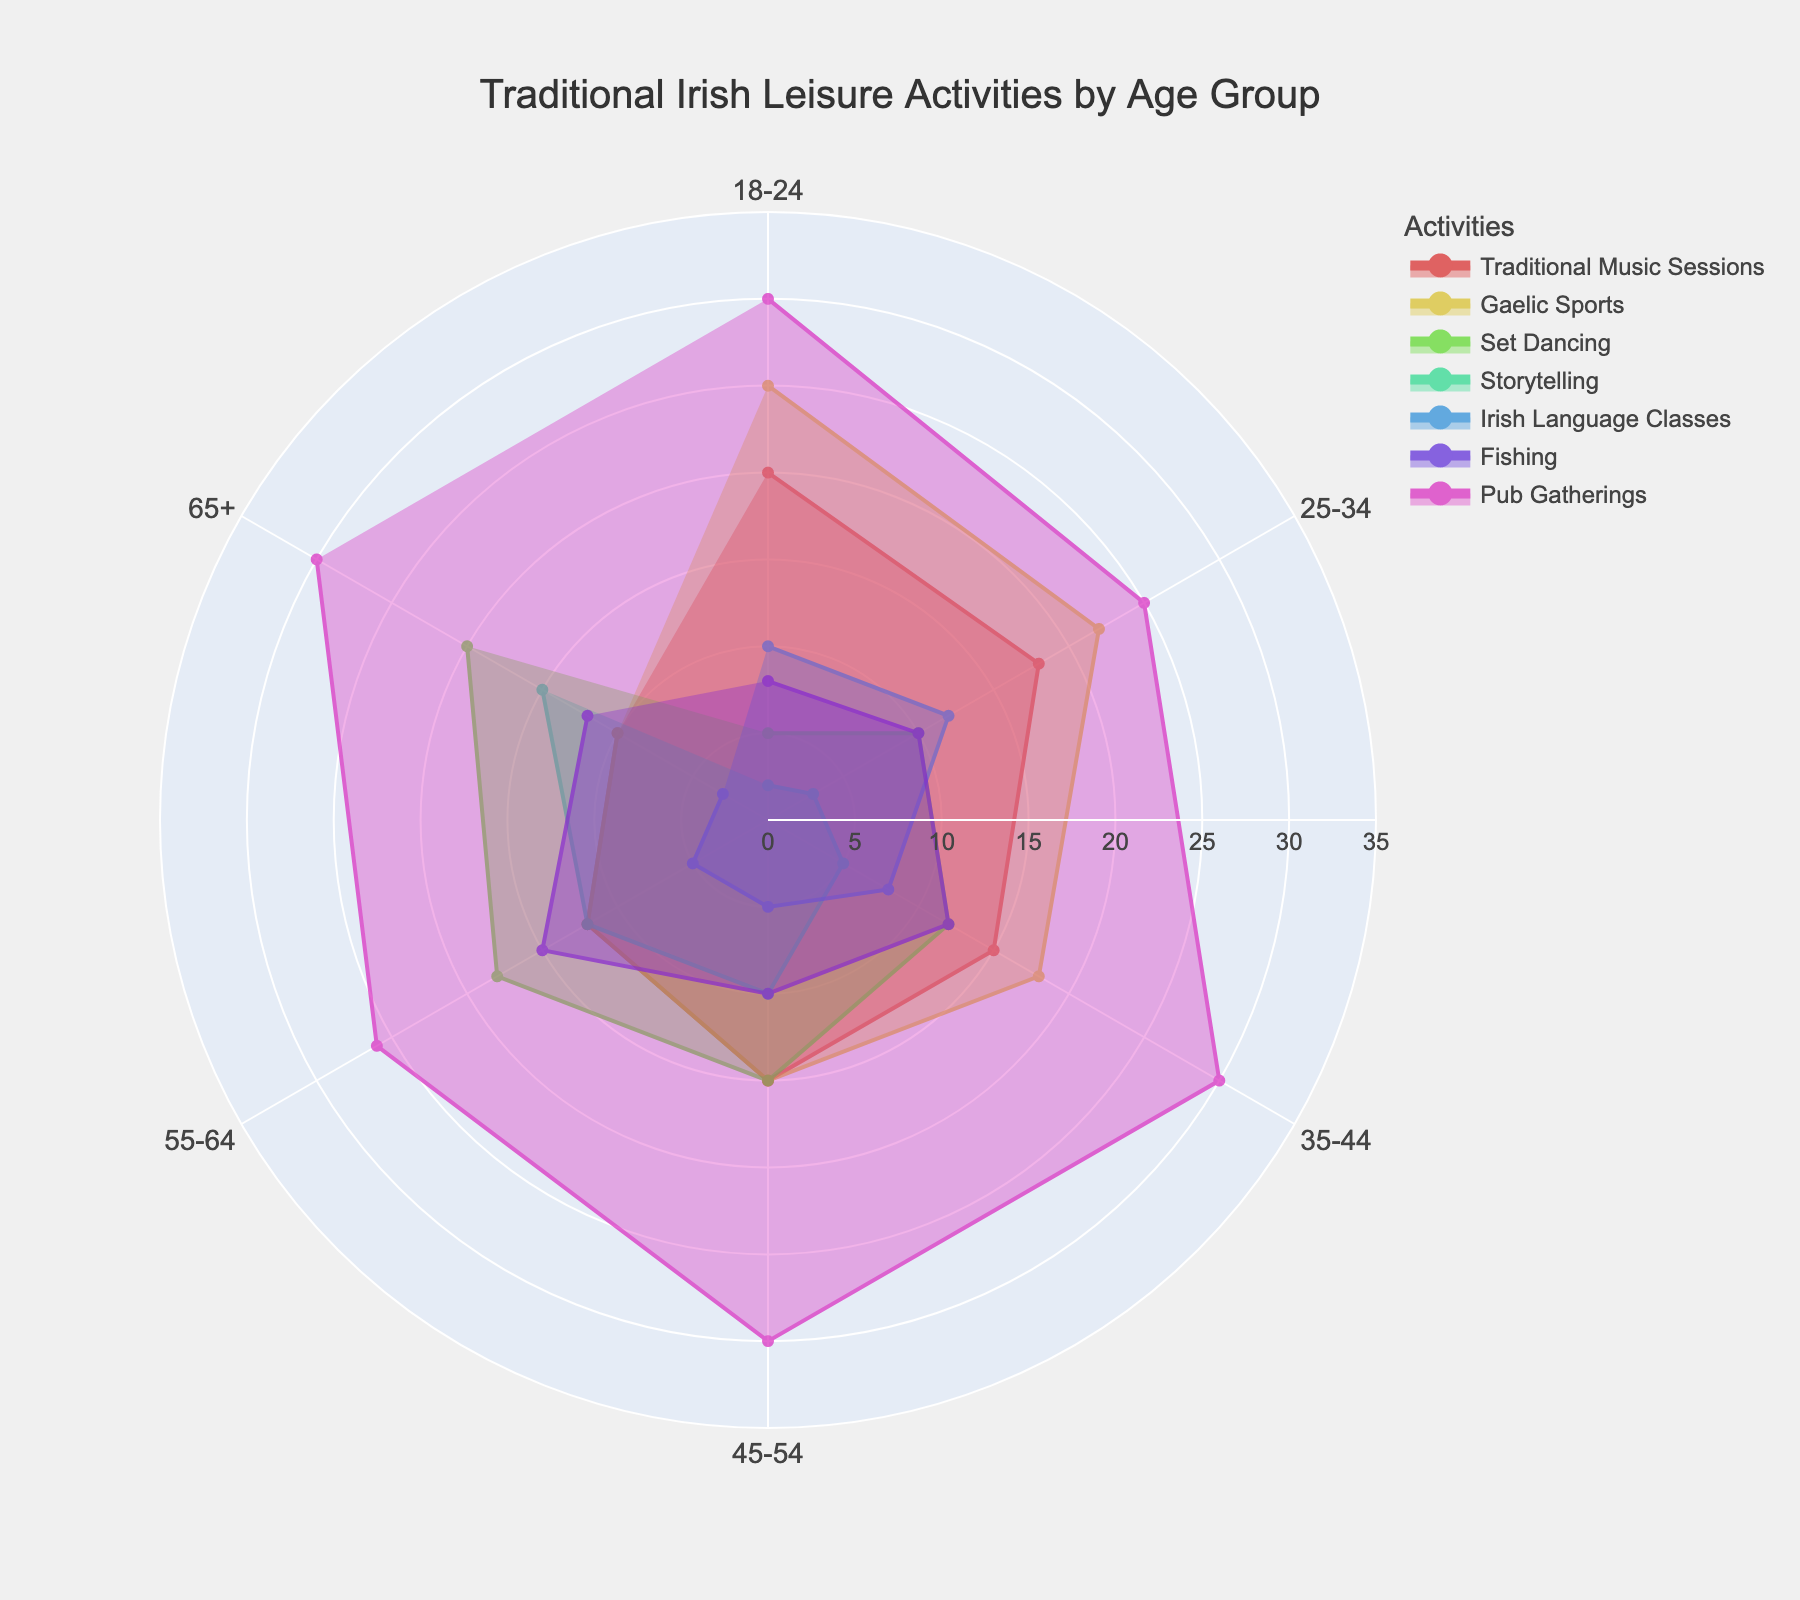What is the most popular leisure activity for the age group 18-24? Look at the section labeled 18-24 to see which activity has the largest circular segment.
Answer: Pub Gatherings Which age group participates the most in Traditional Music Sessions? Compare the circular segments representing Traditional Music Sessions across all age groups to identify the largest one.
Answer: 18-24 What is the combined percentage of Set Dancing and Gaelic Sports for the 45-54 age group? Add the percentages for Set Dancing and Gaelic Sports in the 45-54 age group: 15 + 15.
Answer: 30% Which leisure activity shows a consistent 30% participation across multiple age groups? Check for an activity that has a consistent 30% circular segment across several age groups.
Answer: Pub Gatherings How does participation in Irish Language Classes change from the 18-24 to the 65+ age group? Identify the percentages for Irish Language Classes in the 18-24 and 65+ age groups and compare them.
Answer: Decreases from 10% to 3% What is the difference in percentage of Fishing between the 25-34 and 65+ age groups? Subtract the percentage of Fishing for the 65+ age group from that of the 25-34 age group: 10 - 12.
Answer: -2% Which age group has the highest percentage of participation in Storytelling? Look for the largest segment representing Storytelling among all age groups.
Answer: 65+ How does participation in Gaelic Sports vary with age? Compare the circular segments representing Gaelic Sports across all age groups to observe the pattern.
Answer: Decreases with age What is the total percentage of traditional leisure activities for the age group 35-44? Sum all percentages for the 35-44 age group: 15 + 18 + 12 + 5 + 8 + 12 + 30.
Answer: 100% Is there an age group that shows a peak in Set Dancing participation? Which one? Identify the age group with the highest percentage segment for Set Dancing.
Answer: 65+ 